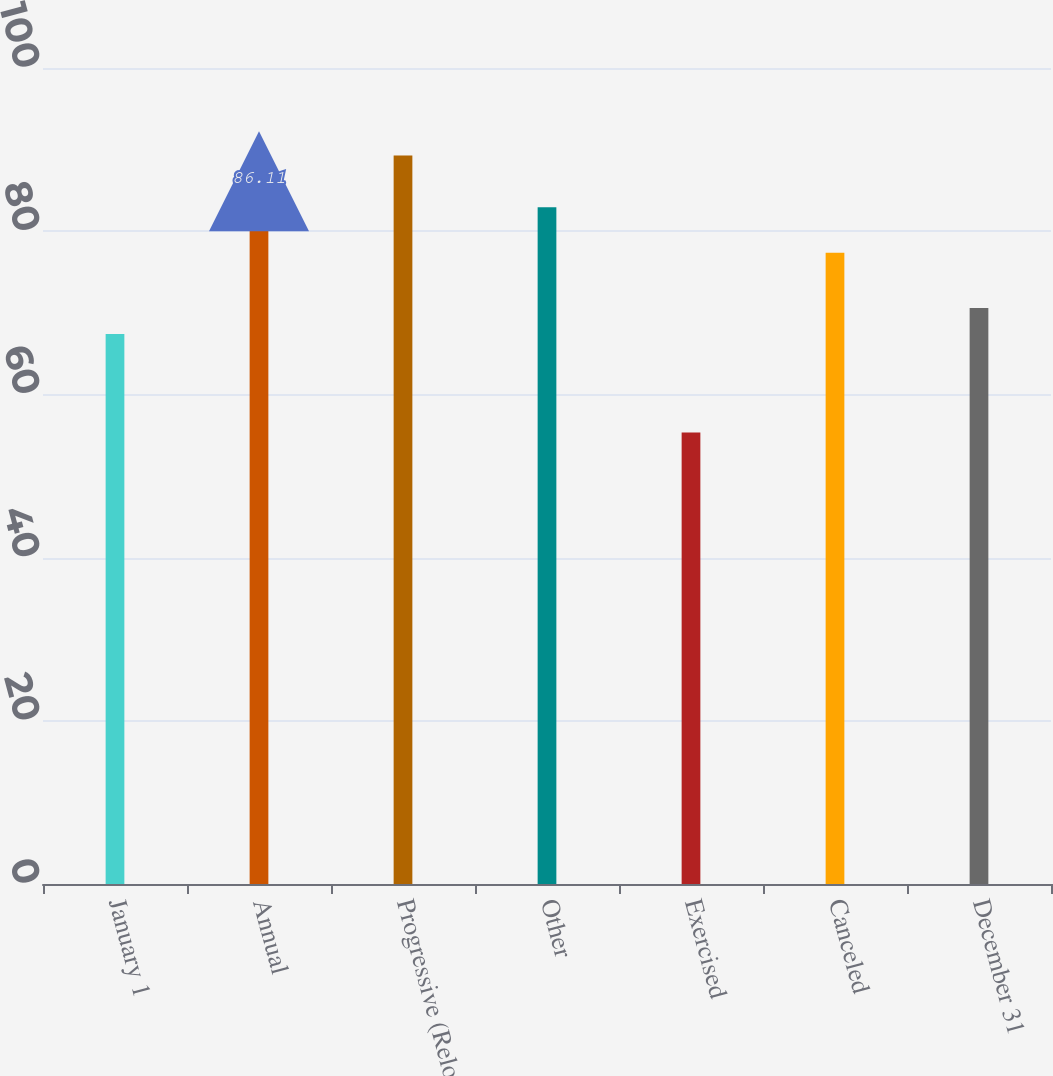Convert chart to OTSL. <chart><loc_0><loc_0><loc_500><loc_500><bar_chart><fcel>January 1<fcel>Annual<fcel>Progressive (Reload)<fcel>Other<fcel>Exercised<fcel>Canceled<fcel>December 31<nl><fcel>67.41<fcel>86.11<fcel>89.29<fcel>82.93<fcel>55.34<fcel>77.36<fcel>70.59<nl></chart> 